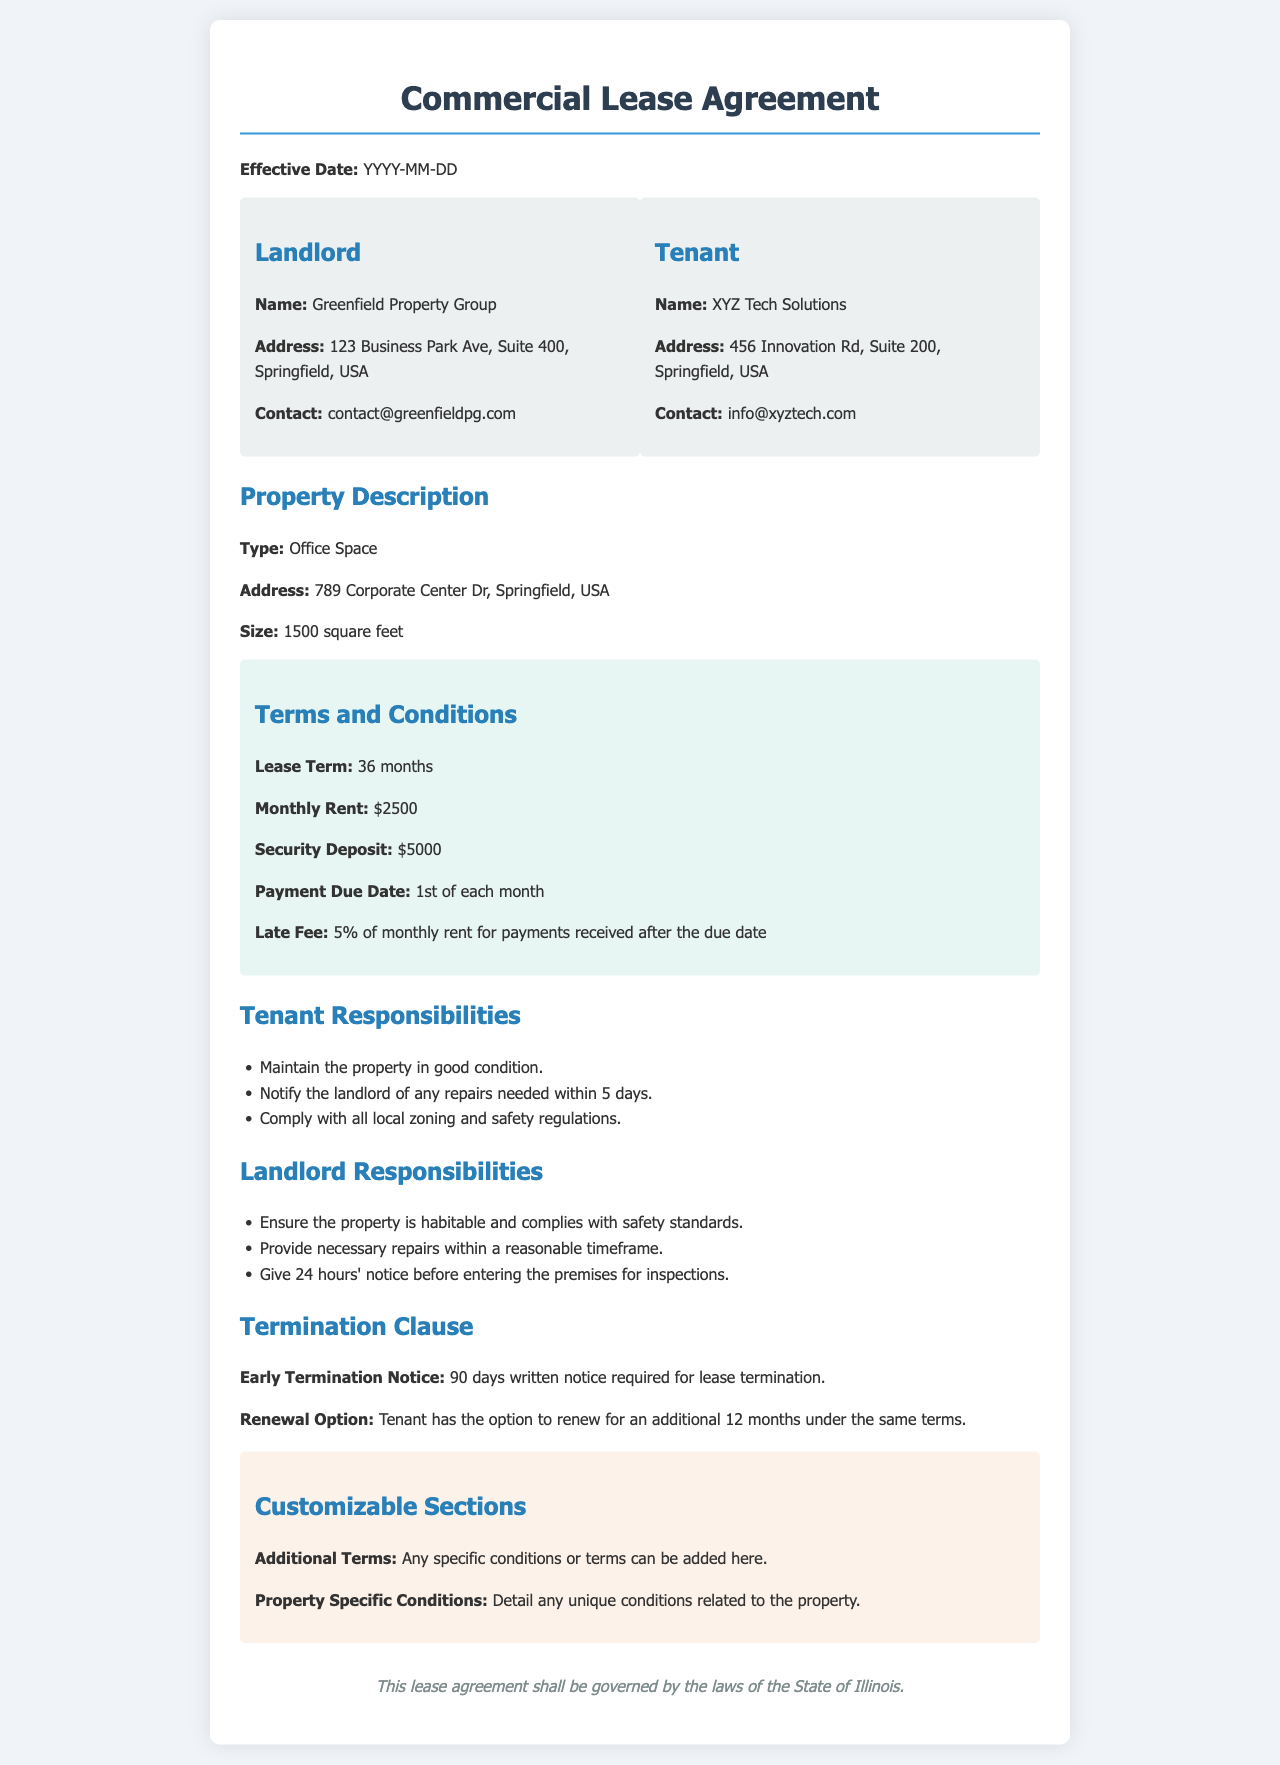What is the effective date of the lease? The effective date is specified at the top of the document as YYYY-MM-DD.
Answer: YYYY-MM-DD Who is the landlord? The landlord's name is mentioned in the party information section.
Answer: Greenfield Property Group What is the monthly rent amount? The monthly rent is indicated in the terms and conditions section.
Answer: $2500 How many square feet is the property? The size of the property is specified in the property description section.
Answer: 1500 square feet What is the security deposit required? The security deposit is listed in the terms and conditions section.
Answer: $5000 What notice is required for early termination of the lease? The amount of notice required is detailed under the termination clause.
Answer: 90 days What responsibility does the tenant have regarding repairs? The tenant's obligation regarding repairs is outlined in the tenant responsibilities section.
Answer: Notify the landlord of any repairs needed within 5 days What option does the tenant have at the end of the lease? The renewal option for the tenant is found in the termination clause.
Answer: Renew for an additional 12 months What color scheme is used for the document's section headings? The colors are specified for the section headings and are a shade of blue.
Answer: Blue 